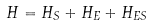Convert formula to latex. <formula><loc_0><loc_0><loc_500><loc_500>H = H _ { S } + H _ { E } + H _ { E S }</formula> 